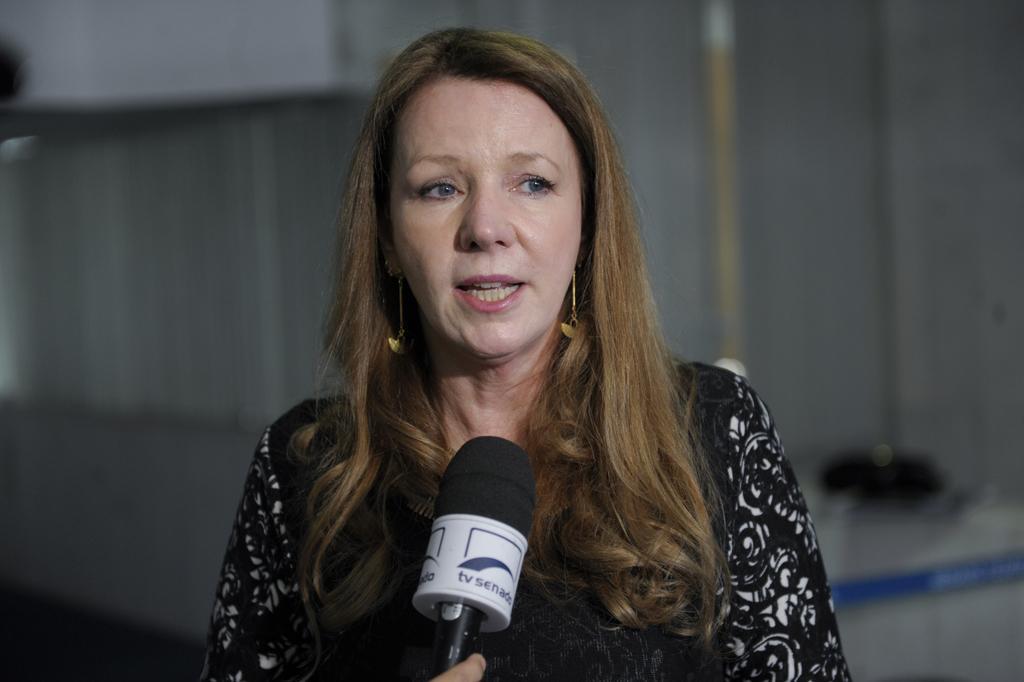Describe this image in one or two sentences. In this image I can see a person standing in-front of the mic. 